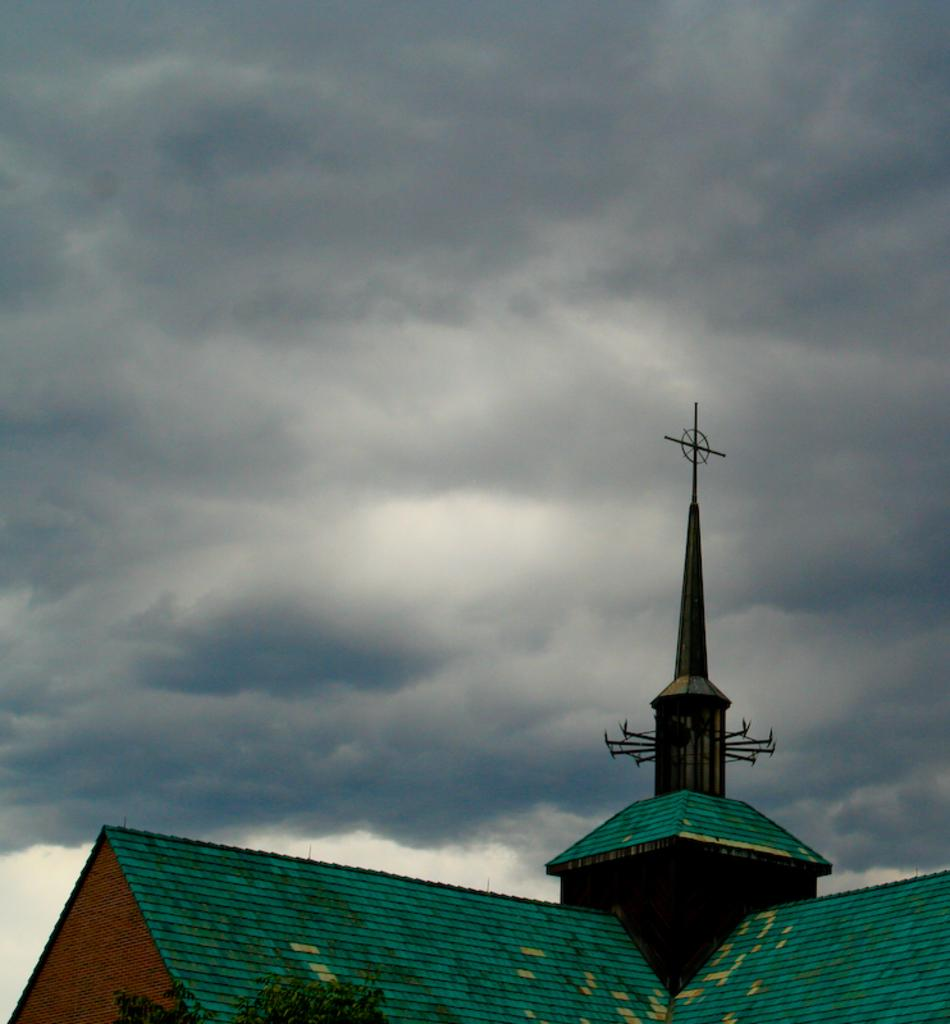What type of structure is present in the image? There is a building in the image. What feature can be seen on the building? There is a tower on the building. What type of vegetation is visible in the image? There is a tree visible in the image. How would you describe the sky in the image? The sky is cloudy in the image. What type of music can be heard coming from the church in the image? There is no church present in the image, so it's not possible to determine what, if any, music might be heard. Can you describe the tub in the image? There is no tub present in the image. 